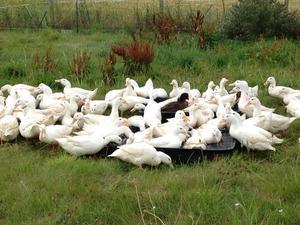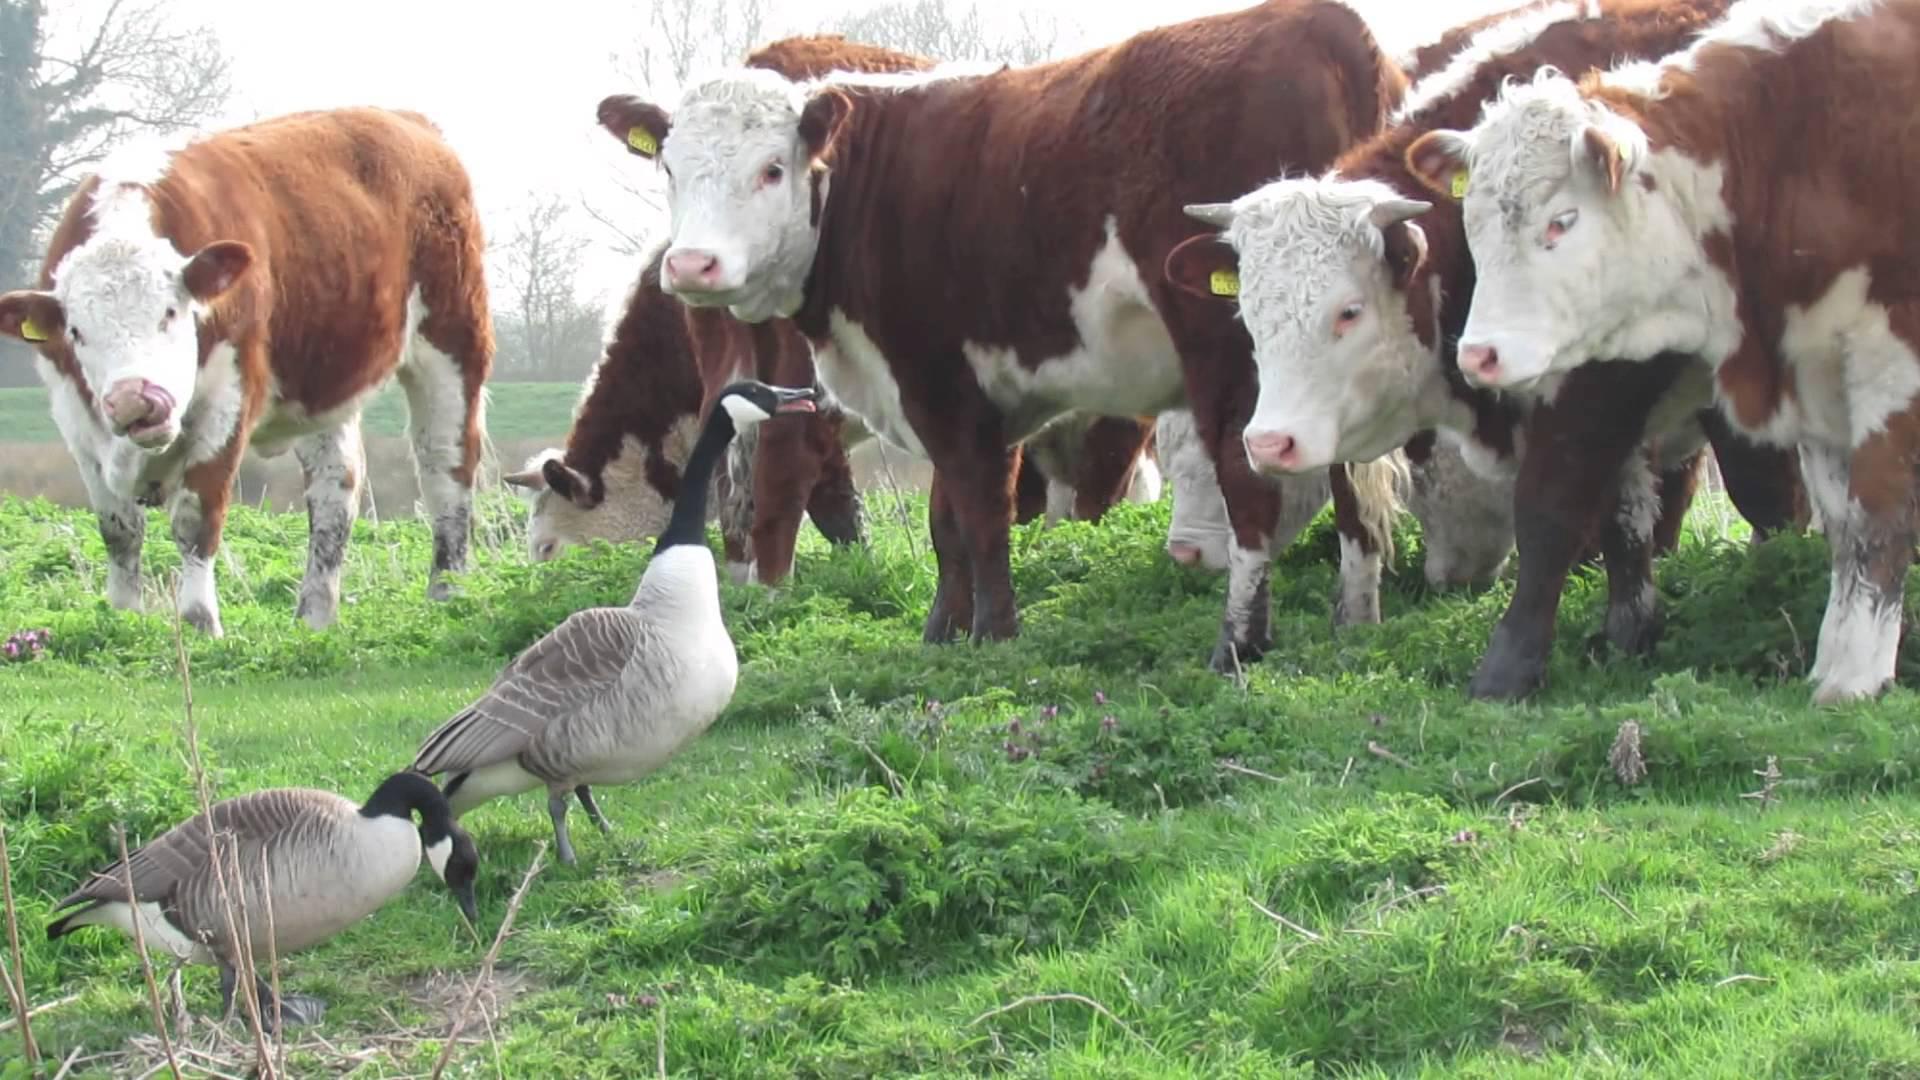The first image is the image on the left, the second image is the image on the right. For the images displayed, is the sentence "An image shows at least eight solid-white ducks moving toward the camera." factually correct? Answer yes or no. No. 